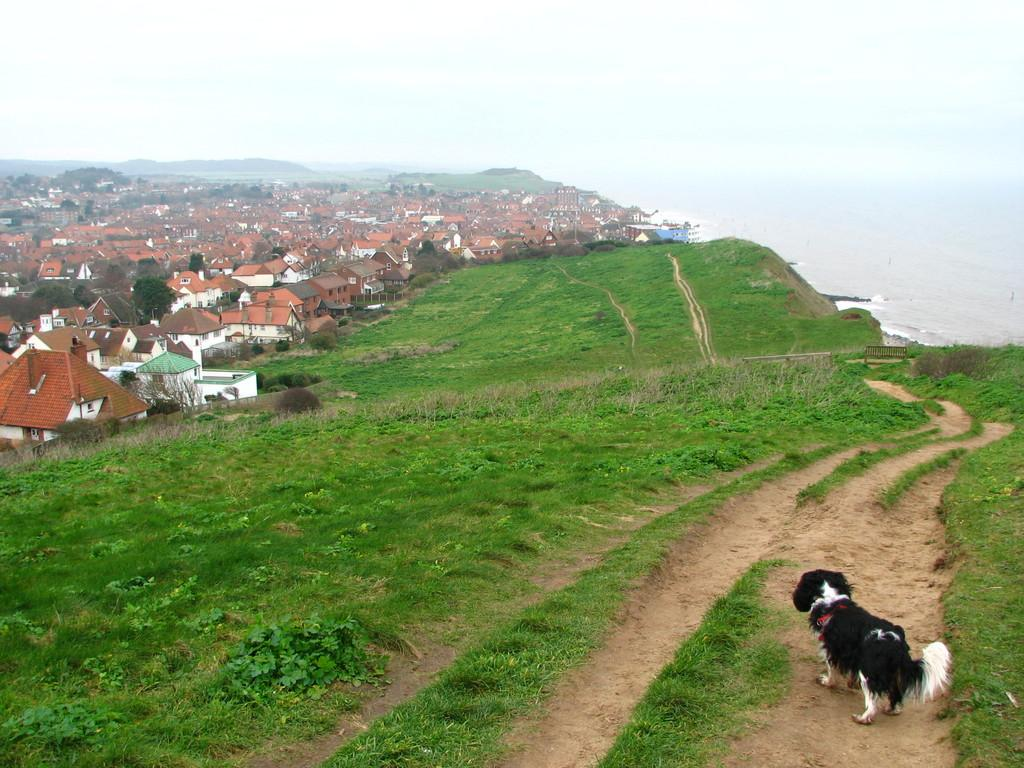What type of structures can be seen in the image? There are buildings in the image. What is on the ground in the image? There is grass on the ground in the image. Can you describe the landscape feature in the image? There is a hill in the image. What type of seating is present in the image? There is a bench in the image. What natural element is visible in the image? There is water visible in the image. What part of the environment is visible in the image? The sky is visible in the image. Are there any animals present in the image? Yes, there is a dog in the image. What type of gun is the dog holding in the image? There is no gun present in the image; the dog is not holding anything. What type of sail can be seen on the bench in the image? There is no sail present in the image; the bench is a stationary object. 